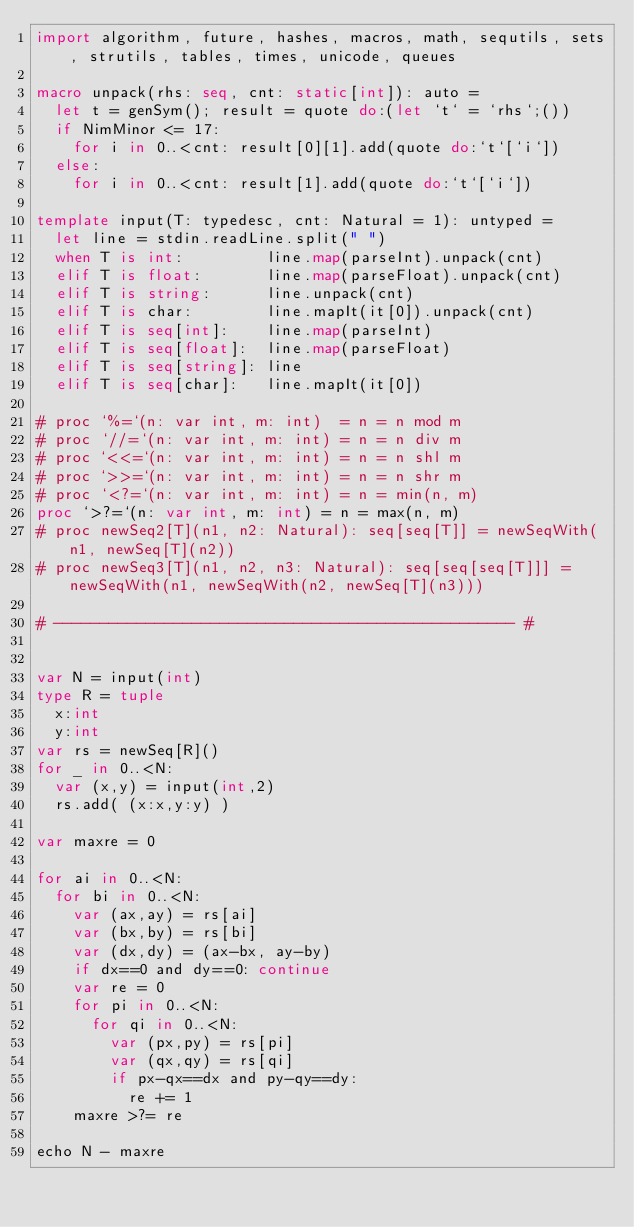Convert code to text. <code><loc_0><loc_0><loc_500><loc_500><_Nim_>import algorithm, future, hashes, macros, math, sequtils, sets, strutils, tables, times, unicode, queues
 
macro unpack(rhs: seq, cnt: static[int]): auto =
  let t = genSym(); result = quote do:(let `t` = `rhs`;())
  if NimMinor <= 17:
    for i in 0..<cnt: result[0][1].add(quote do:`t`[`i`])
  else:
    for i in 0..<cnt: result[1].add(quote do:`t`[`i`])
 
template input(T: typedesc, cnt: Natural = 1): untyped =
  let line = stdin.readLine.split(" ")
  when T is int:         line.map(parseInt).unpack(cnt)
  elif T is float:       line.map(parseFloat).unpack(cnt)
  elif T is string:      line.unpack(cnt)
  elif T is char:        line.mapIt(it[0]).unpack(cnt)
  elif T is seq[int]:    line.map(parseInt)
  elif T is seq[float]:  line.map(parseFloat)
  elif T is seq[string]: line
  elif T is seq[char]:   line.mapIt(it[0])
 
# proc `%=`(n: var int, m: int)  = n = n mod m
# proc `//=`(n: var int, m: int) = n = n div m
# proc `<<=`(n: var int, m: int) = n = n shl m
# proc `>>=`(n: var int, m: int) = n = n shr m
# proc `<?=`(n: var int, m: int) = n = min(n, m)
proc `>?=`(n: var int, m: int) = n = max(n, m)
# proc newSeq2[T](n1, n2: Natural): seq[seq[T]] = newSeqWith(n1, newSeq[T](n2))
# proc newSeq3[T](n1, n2, n3: Natural): seq[seq[seq[T]]] = newSeqWith(n1, newSeqWith(n2, newSeq[T](n3)))
 
# -------------------------------------------------- #


var N = input(int)
type R = tuple
  x:int
  y:int
var rs = newSeq[R]()
for _ in 0..<N:
  var (x,y) = input(int,2)
  rs.add( (x:x,y:y) )

var maxre = 0

for ai in 0..<N:
  for bi in 0..<N:
    var (ax,ay) = rs[ai]
    var (bx,by) = rs[bi]
    var (dx,dy) = (ax-bx, ay-by)
    if dx==0 and dy==0: continue
    var re = 0
    for pi in 0..<N:
      for qi in 0..<N:
        var (px,py) = rs[pi]
        var (qx,qy) = rs[qi]
        if px-qx==dx and py-qy==dy:
          re += 1
    maxre >?= re

echo N - maxre

</code> 